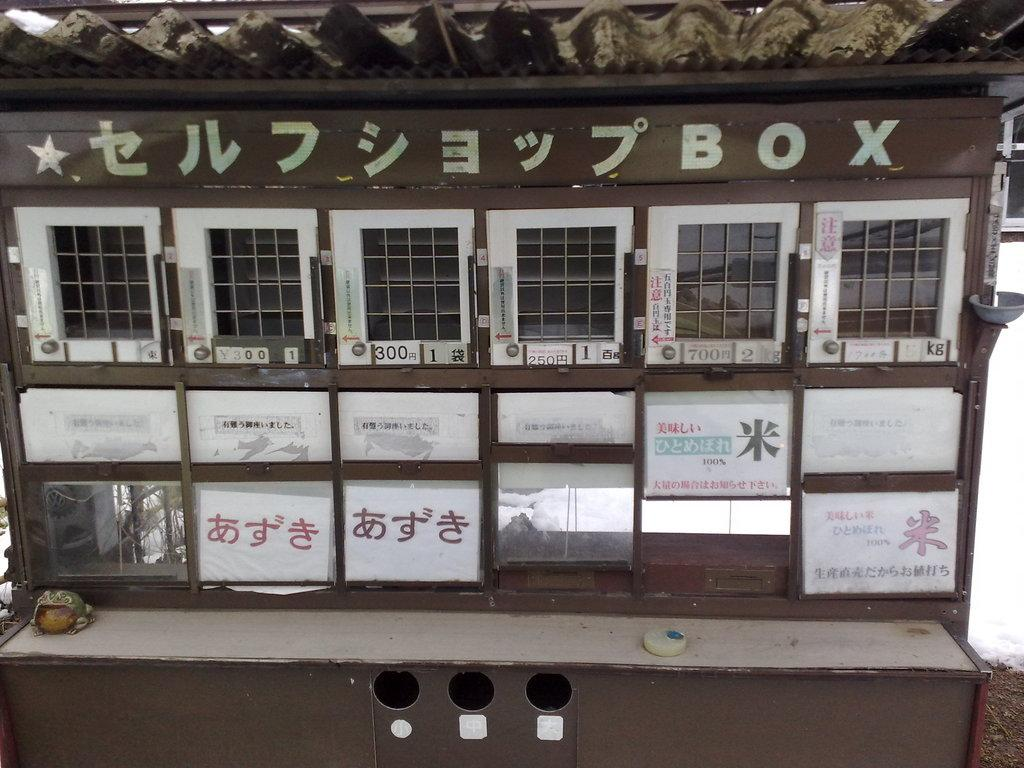What type of architectural feature is present in the image? There are small doors in the image. What type of decorations are present in the image? There are posters in the image. What material is present in the image? There is glass in the image. What type of surface is present in the image? There are objects on a platform in the image. What type of fabric is present in the image? There is a sheet in the image. What type of pencil can be seen drawing on the sheet in the image? There is no pencil present in the image, and therefore no such activity can be observed. What time of day is depicted in the image? The time of day is not mentioned or depicted in the image. 